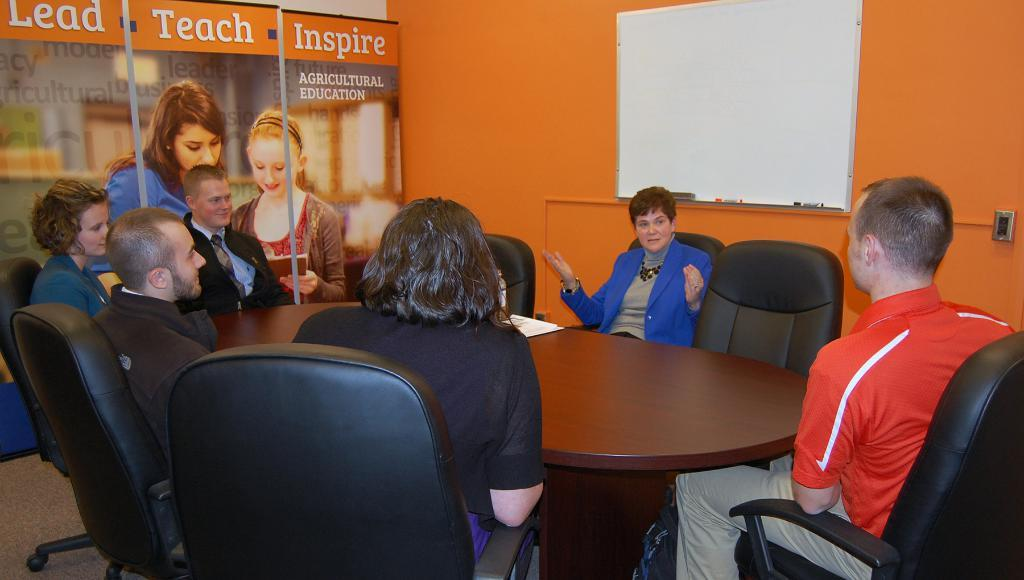What is the arrangement of the people in the image? There are people sitting around a circular table. What is the color of the table? The table is brown in color. Can you describe any objects in the background? There is an orange bowl in the background. What is present on the left side of the image? There is a poster on the left side of the image. Are there any children attending school in the image? There is no reference to children or school in the image. What type of linen is draped over the table in the image? There is no linen present in the image; the table is brown. 